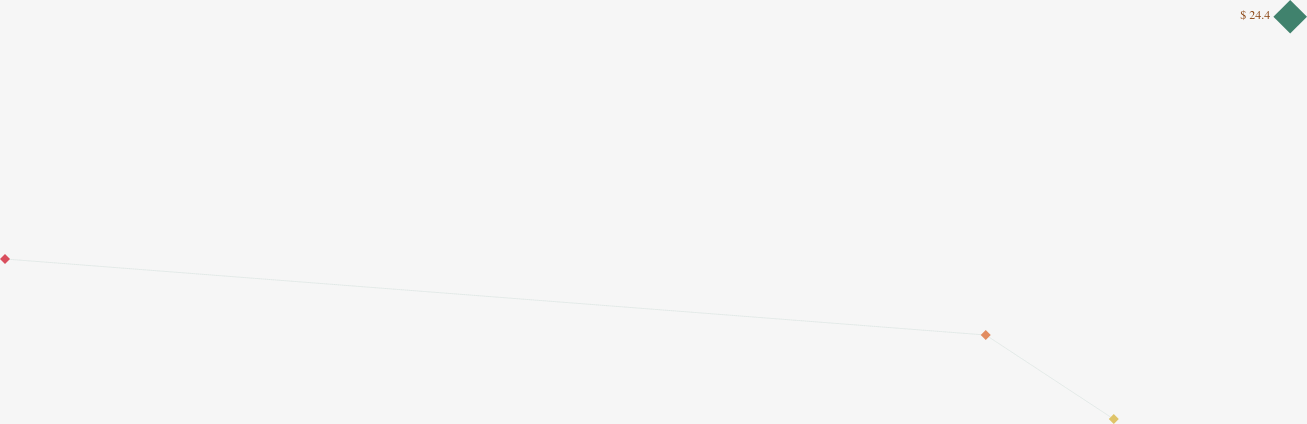Convert chart to OTSL. <chart><loc_0><loc_0><loc_500><loc_500><line_chart><ecel><fcel>$ 24.4<nl><fcel>1814.59<fcel>21.12<nl><fcel>2258.3<fcel>19.14<nl><fcel>2316.21<fcel>16.95<nl><fcel>2393.67<fcel>13.35<nl></chart> 